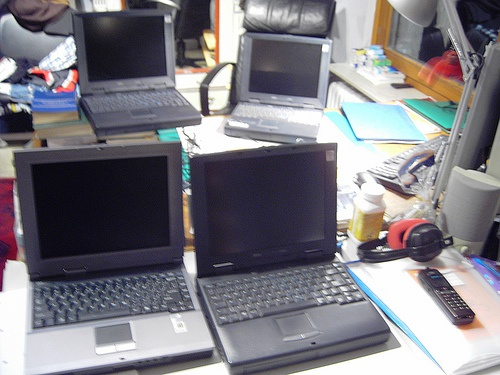Describe the objects in this image and their specific colors. I can see laptop in gray, black, and lightgray tones, laptop in gray, black, darkgray, and navy tones, laptop in gray and black tones, laptop in gray, lightgray, darkgray, and black tones, and keyboard in gray, navy, and darkgray tones in this image. 